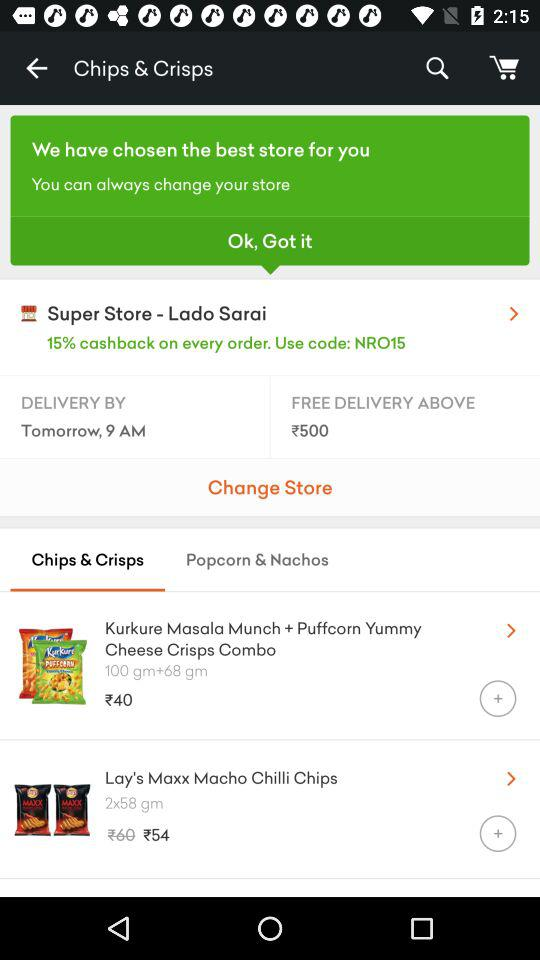What is the code to get cashback? The code is "NRO15". 